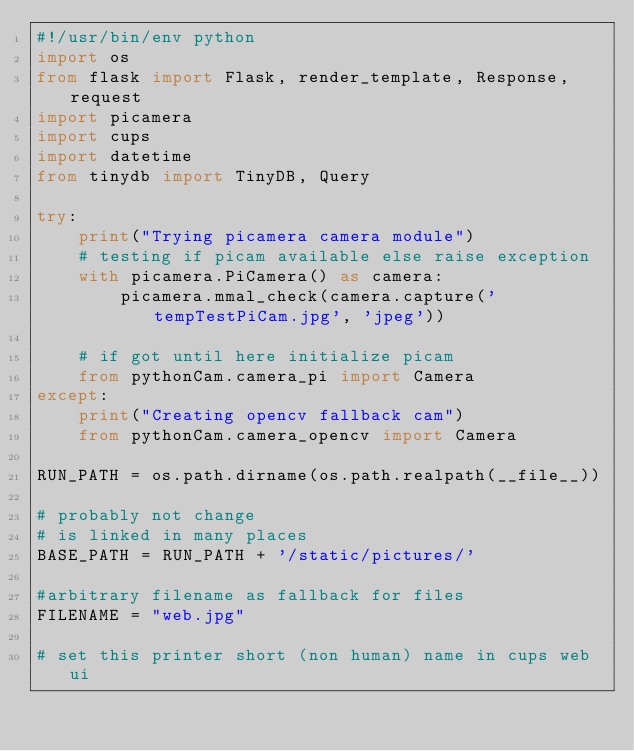<code> <loc_0><loc_0><loc_500><loc_500><_Python_>#!/usr/bin/env python
import os
from flask import Flask, render_template, Response, request
import picamera
import cups
import datetime
from tinydb import TinyDB, Query

try:
    print("Trying picamera camera module")
    # testing if picam available else raise exception
    with picamera.PiCamera() as camera:
        picamera.mmal_check(camera.capture('tempTestPiCam.jpg', 'jpeg'))

    # if got until here initialize picam
    from pythonCam.camera_pi import Camera
except:
    print("Creating opencv fallback cam")
    from pythonCam.camera_opencv import Camera

RUN_PATH = os.path.dirname(os.path.realpath(__file__))

# probably not change
# is linked in many places
BASE_PATH = RUN_PATH + '/static/pictures/'

#arbitrary filename as fallback for files
FILENAME = "web.jpg"

# set this printer short (non human) name in cups web ui</code> 